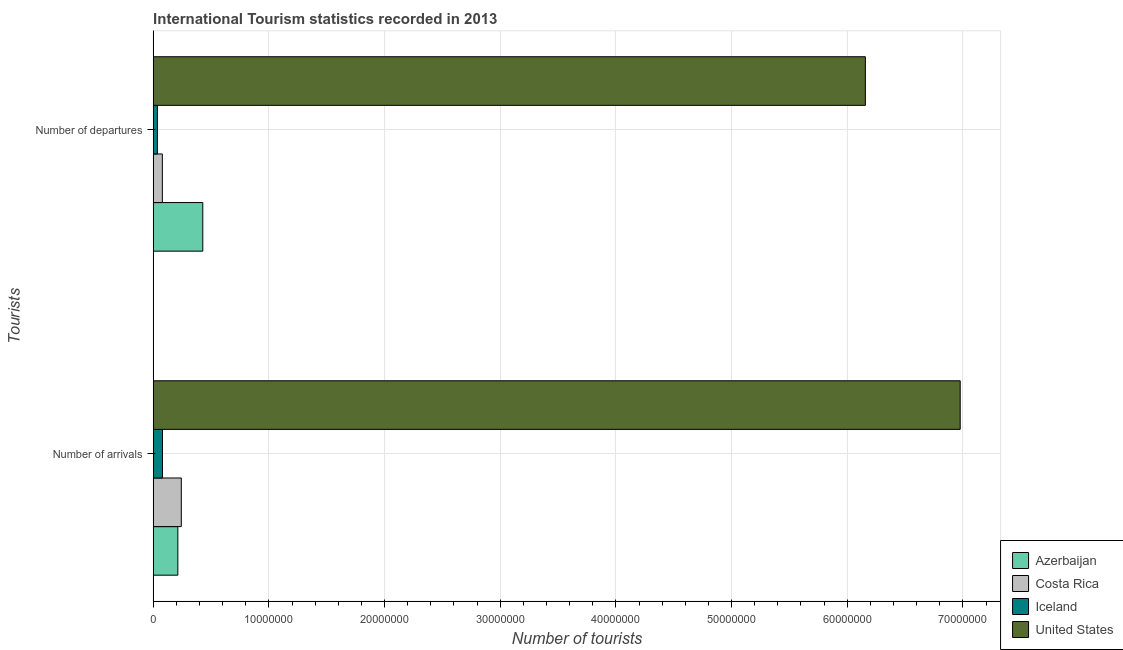How many different coloured bars are there?
Your response must be concise. 4. Are the number of bars per tick equal to the number of legend labels?
Offer a very short reply. Yes. Are the number of bars on each tick of the Y-axis equal?
Offer a very short reply. Yes. How many bars are there on the 2nd tick from the bottom?
Give a very brief answer. 4. What is the label of the 2nd group of bars from the top?
Keep it short and to the point. Number of arrivals. What is the number of tourist arrivals in Iceland?
Provide a short and direct response. 8.00e+05. Across all countries, what is the maximum number of tourist departures?
Provide a short and direct response. 6.16e+07. Across all countries, what is the minimum number of tourist arrivals?
Give a very brief answer. 8.00e+05. In which country was the number of tourist arrivals maximum?
Ensure brevity in your answer.  United States. In which country was the number of tourist arrivals minimum?
Provide a succinct answer. Iceland. What is the total number of tourist arrivals in the graph?
Make the answer very short. 7.51e+07. What is the difference between the number of tourist arrivals in Iceland and that in United States?
Your response must be concise. -6.90e+07. What is the difference between the number of tourist arrivals in Costa Rica and the number of tourist departures in United States?
Your answer should be compact. -5.91e+07. What is the average number of tourist departures per country?
Keep it short and to the point. 1.68e+07. What is the difference between the number of tourist departures and number of tourist arrivals in United States?
Provide a short and direct response. -8.20e+06. In how many countries, is the number of tourist arrivals greater than 22000000 ?
Give a very brief answer. 1. What is the ratio of the number of tourist arrivals in Iceland to that in United States?
Your answer should be compact. 0.01. Is the number of tourist arrivals in Azerbaijan less than that in Costa Rica?
Offer a very short reply. Yes. What does the 2nd bar from the top in Number of arrivals represents?
Provide a succinct answer. Iceland. How many bars are there?
Your response must be concise. 8. What is the difference between two consecutive major ticks on the X-axis?
Make the answer very short. 1.00e+07. Are the values on the major ticks of X-axis written in scientific E-notation?
Give a very brief answer. No. Does the graph contain grids?
Make the answer very short. Yes. Where does the legend appear in the graph?
Keep it short and to the point. Bottom right. How many legend labels are there?
Your answer should be very brief. 4. How are the legend labels stacked?
Keep it short and to the point. Vertical. What is the title of the graph?
Offer a terse response. International Tourism statistics recorded in 2013. What is the label or title of the X-axis?
Your answer should be very brief. Number of tourists. What is the label or title of the Y-axis?
Your response must be concise. Tourists. What is the Number of tourists of Azerbaijan in Number of arrivals?
Provide a succinct answer. 2.13e+06. What is the Number of tourists in Costa Rica in Number of arrivals?
Make the answer very short. 2.43e+06. What is the Number of tourists of United States in Number of arrivals?
Provide a short and direct response. 6.98e+07. What is the Number of tourists in Azerbaijan in Number of departures?
Your answer should be very brief. 4.28e+06. What is the Number of tourists of Costa Rica in Number of departures?
Ensure brevity in your answer.  7.90e+05. What is the Number of tourists of Iceland in Number of departures?
Offer a terse response. 3.65e+05. What is the Number of tourists in United States in Number of departures?
Offer a terse response. 6.16e+07. Across all Tourists, what is the maximum Number of tourists of Azerbaijan?
Offer a terse response. 4.28e+06. Across all Tourists, what is the maximum Number of tourists in Costa Rica?
Offer a very short reply. 2.43e+06. Across all Tourists, what is the maximum Number of tourists of United States?
Offer a very short reply. 6.98e+07. Across all Tourists, what is the minimum Number of tourists in Azerbaijan?
Make the answer very short. 2.13e+06. Across all Tourists, what is the minimum Number of tourists in Costa Rica?
Ensure brevity in your answer.  7.90e+05. Across all Tourists, what is the minimum Number of tourists in Iceland?
Your response must be concise. 3.65e+05. Across all Tourists, what is the minimum Number of tourists in United States?
Give a very brief answer. 6.16e+07. What is the total Number of tourists of Azerbaijan in the graph?
Your response must be concise. 6.42e+06. What is the total Number of tourists of Costa Rica in the graph?
Your response must be concise. 3.22e+06. What is the total Number of tourists in Iceland in the graph?
Your response must be concise. 1.16e+06. What is the total Number of tourists in United States in the graph?
Make the answer very short. 1.31e+08. What is the difference between the Number of tourists in Azerbaijan in Number of arrivals and that in Number of departures?
Offer a terse response. -2.16e+06. What is the difference between the Number of tourists of Costa Rica in Number of arrivals and that in Number of departures?
Your answer should be compact. 1.64e+06. What is the difference between the Number of tourists in Iceland in Number of arrivals and that in Number of departures?
Provide a short and direct response. 4.35e+05. What is the difference between the Number of tourists of United States in Number of arrivals and that in Number of departures?
Make the answer very short. 8.20e+06. What is the difference between the Number of tourists of Azerbaijan in Number of arrivals and the Number of tourists of Costa Rica in Number of departures?
Provide a short and direct response. 1.34e+06. What is the difference between the Number of tourists of Azerbaijan in Number of arrivals and the Number of tourists of Iceland in Number of departures?
Provide a succinct answer. 1.76e+06. What is the difference between the Number of tourists in Azerbaijan in Number of arrivals and the Number of tourists in United States in Number of departures?
Offer a very short reply. -5.94e+07. What is the difference between the Number of tourists in Costa Rica in Number of arrivals and the Number of tourists in Iceland in Number of departures?
Provide a short and direct response. 2.06e+06. What is the difference between the Number of tourists in Costa Rica in Number of arrivals and the Number of tourists in United States in Number of departures?
Your response must be concise. -5.91e+07. What is the difference between the Number of tourists of Iceland in Number of arrivals and the Number of tourists of United States in Number of departures?
Provide a succinct answer. -6.08e+07. What is the average Number of tourists of Azerbaijan per Tourists?
Make the answer very short. 3.21e+06. What is the average Number of tourists in Costa Rica per Tourists?
Your answer should be compact. 1.61e+06. What is the average Number of tourists in Iceland per Tourists?
Ensure brevity in your answer.  5.82e+05. What is the average Number of tourists of United States per Tourists?
Your response must be concise. 6.57e+07. What is the difference between the Number of tourists in Azerbaijan and Number of tourists in Costa Rica in Number of arrivals?
Provide a short and direct response. -2.98e+05. What is the difference between the Number of tourists in Azerbaijan and Number of tourists in Iceland in Number of arrivals?
Make the answer very short. 1.33e+06. What is the difference between the Number of tourists of Azerbaijan and Number of tourists of United States in Number of arrivals?
Ensure brevity in your answer.  -6.76e+07. What is the difference between the Number of tourists in Costa Rica and Number of tourists in Iceland in Number of arrivals?
Provide a short and direct response. 1.63e+06. What is the difference between the Number of tourists of Costa Rica and Number of tourists of United States in Number of arrivals?
Keep it short and to the point. -6.73e+07. What is the difference between the Number of tourists of Iceland and Number of tourists of United States in Number of arrivals?
Your answer should be compact. -6.90e+07. What is the difference between the Number of tourists in Azerbaijan and Number of tourists in Costa Rica in Number of departures?
Make the answer very short. 3.50e+06. What is the difference between the Number of tourists in Azerbaijan and Number of tourists in Iceland in Number of departures?
Your answer should be very brief. 3.92e+06. What is the difference between the Number of tourists in Azerbaijan and Number of tourists in United States in Number of departures?
Give a very brief answer. -5.73e+07. What is the difference between the Number of tourists in Costa Rica and Number of tourists in Iceland in Number of departures?
Your response must be concise. 4.25e+05. What is the difference between the Number of tourists of Costa Rica and Number of tourists of United States in Number of departures?
Provide a short and direct response. -6.08e+07. What is the difference between the Number of tourists of Iceland and Number of tourists of United States in Number of departures?
Keep it short and to the point. -6.12e+07. What is the ratio of the Number of tourists in Azerbaijan in Number of arrivals to that in Number of departures?
Offer a very short reply. 0.5. What is the ratio of the Number of tourists in Costa Rica in Number of arrivals to that in Number of departures?
Your answer should be very brief. 3.07. What is the ratio of the Number of tourists of Iceland in Number of arrivals to that in Number of departures?
Give a very brief answer. 2.19. What is the ratio of the Number of tourists of United States in Number of arrivals to that in Number of departures?
Ensure brevity in your answer.  1.13. What is the difference between the highest and the second highest Number of tourists in Azerbaijan?
Offer a terse response. 2.16e+06. What is the difference between the highest and the second highest Number of tourists of Costa Rica?
Give a very brief answer. 1.64e+06. What is the difference between the highest and the second highest Number of tourists in Iceland?
Make the answer very short. 4.35e+05. What is the difference between the highest and the second highest Number of tourists in United States?
Provide a succinct answer. 8.20e+06. What is the difference between the highest and the lowest Number of tourists of Azerbaijan?
Keep it short and to the point. 2.16e+06. What is the difference between the highest and the lowest Number of tourists in Costa Rica?
Offer a very short reply. 1.64e+06. What is the difference between the highest and the lowest Number of tourists of Iceland?
Offer a very short reply. 4.35e+05. What is the difference between the highest and the lowest Number of tourists in United States?
Your answer should be compact. 8.20e+06. 